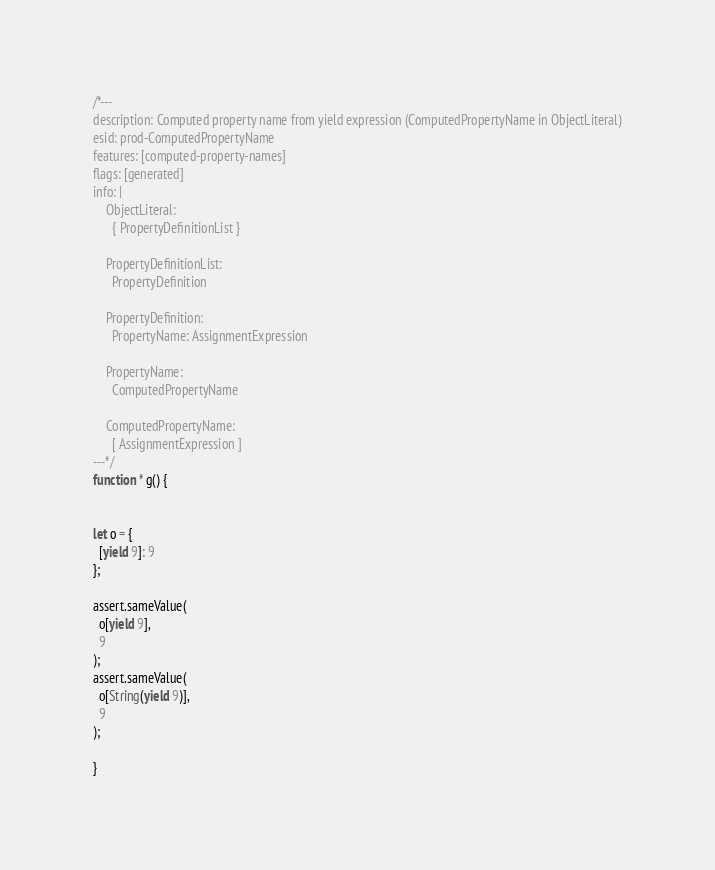Convert code to text. <code><loc_0><loc_0><loc_500><loc_500><_JavaScript_>/*---
description: Computed property name from yield expression (ComputedPropertyName in ObjectLiteral)
esid: prod-ComputedPropertyName
features: [computed-property-names]
flags: [generated]
info: |
    ObjectLiteral:
      { PropertyDefinitionList }

    PropertyDefinitionList:
      PropertyDefinition

    PropertyDefinition:
      PropertyName: AssignmentExpression

    PropertyName:
      ComputedPropertyName

    ComputedPropertyName:
      [ AssignmentExpression ]
---*/
function * g() {


let o = {
  [yield 9]: 9
};

assert.sameValue(
  o[yield 9],
  9
);
assert.sameValue(
  o[String(yield 9)],
  9
);

}
</code> 